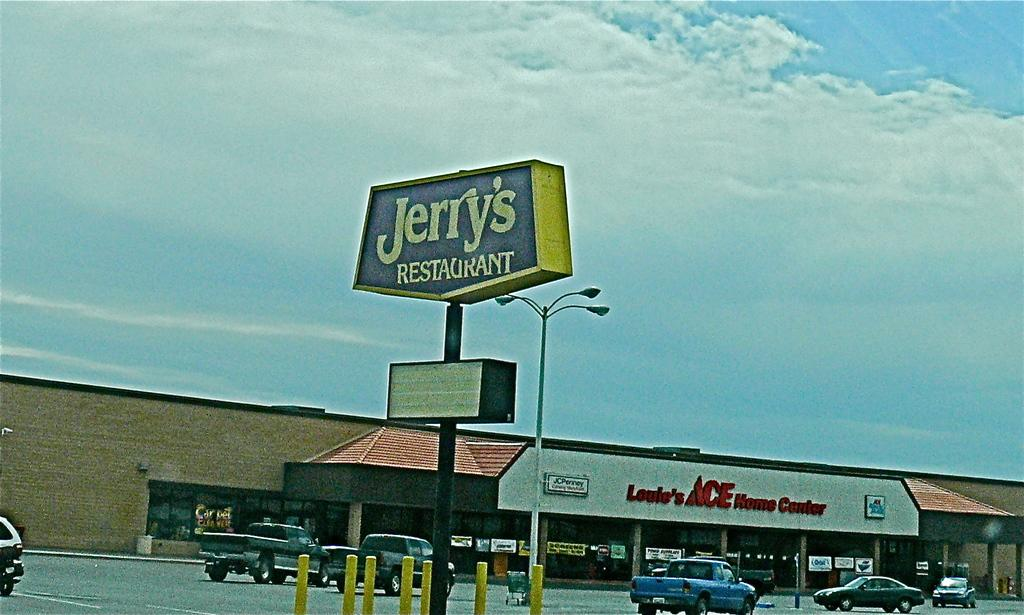<image>
Share a concise interpretation of the image provided. A sign for Jerry's Restaurant stands in a plaza parking lot. 